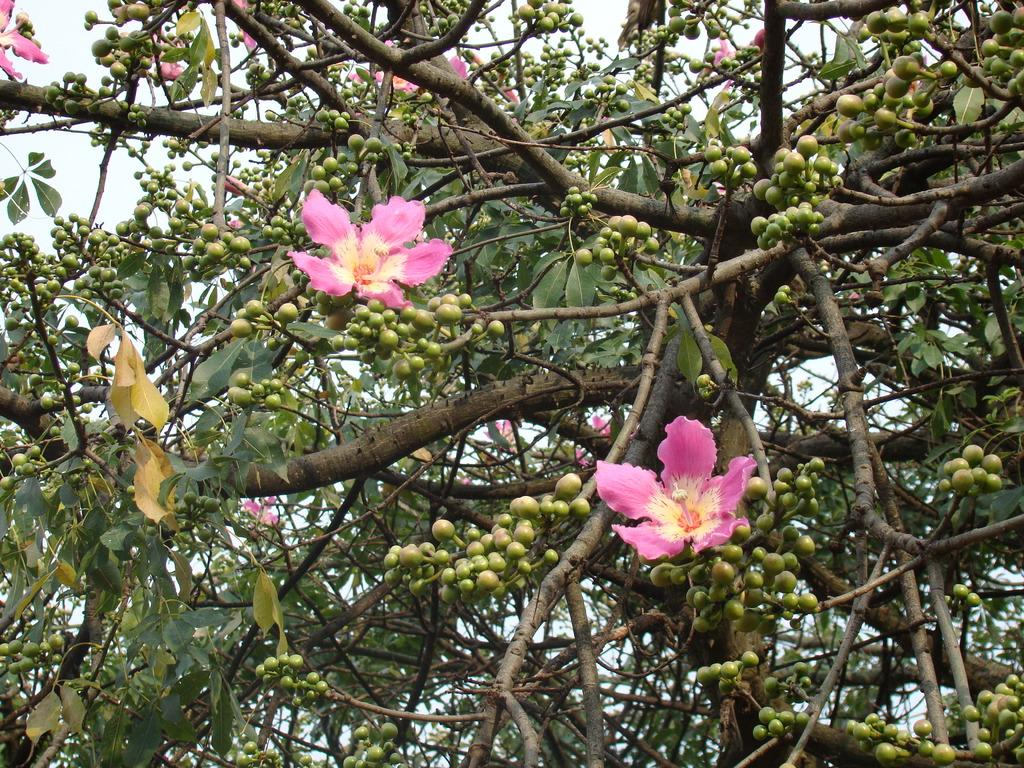What is the main subject of the picture? The main subject of the picture is a tree. What features can be observed on the tree? The tree has flowers and fruits. What can be seen in the background of the picture? The sky is visible in the background of the picture. What type of rhythm can be heard coming from the tree in the image? There is no sound or rhythm associated with the tree in the image. 